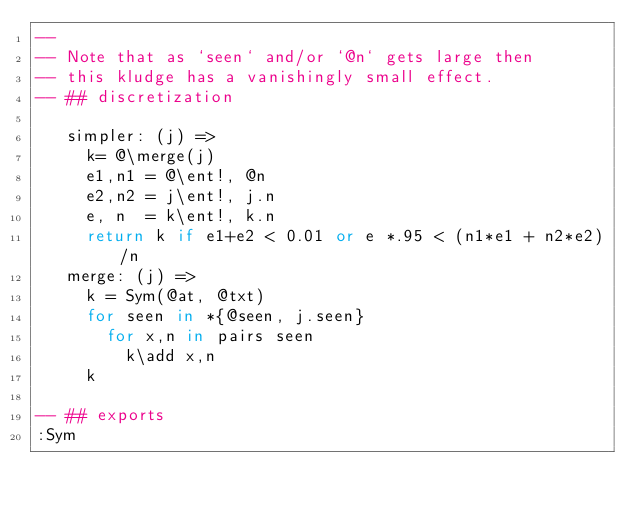<code> <loc_0><loc_0><loc_500><loc_500><_MoonScript_>--
-- Note that as `seen` and/or `@n` gets large then
-- this kludge has a vanishingly small effect.
-- ## discretization

   simpler: (j) =>
     k= @\merge(j)
     e1,n1 = @\ent!, @n
     e2,n2 = j\ent!, j.n
     e, n  = k\ent!, k.n
     return k if e1+e2 < 0.01 or e *.95 < (n1*e1 + n2*e2)/n
   merge: (j) =>
     k = Sym(@at, @txt)
     for seen in *{@seen, j.seen}
       for x,n in pairs seen 
         k\add x,n
     k

-- ## exports
:Sym
</code> 